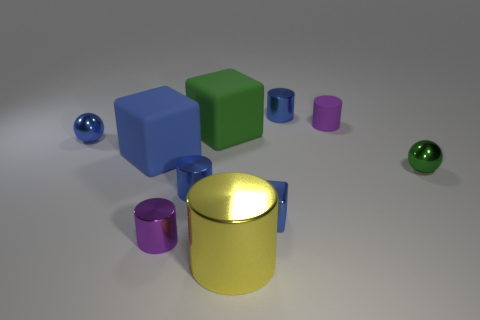There is a thing that is the same color as the tiny matte cylinder; what is its material?
Ensure brevity in your answer.  Metal. There is a small ball on the left side of the large cylinder; is its color the same as the metallic cube?
Offer a terse response. Yes. The blue object that is to the right of the large yellow metallic cylinder and behind the small green shiny sphere is made of what material?
Your answer should be very brief. Metal. There is a blue thing that is the same size as the green cube; what is its material?
Offer a very short reply. Rubber. What is the size of the blue cylinder on the left side of the small metal cylinder that is behind the blue metallic cylinder that is in front of the purple matte cylinder?
Ensure brevity in your answer.  Small. The yellow cylinder that is the same material as the small green ball is what size?
Your response must be concise. Large. Does the yellow cylinder have the same size as the purple object that is to the left of the metal block?
Provide a succinct answer. No. There is a tiny purple thing that is left of the yellow metallic object; what shape is it?
Provide a succinct answer. Cylinder. There is a rubber thing on the right side of the big block behind the big blue thing; are there any blue rubber things on the left side of it?
Your response must be concise. Yes. There is a tiny blue thing that is the same shape as the small green metallic thing; what material is it?
Ensure brevity in your answer.  Metal. 